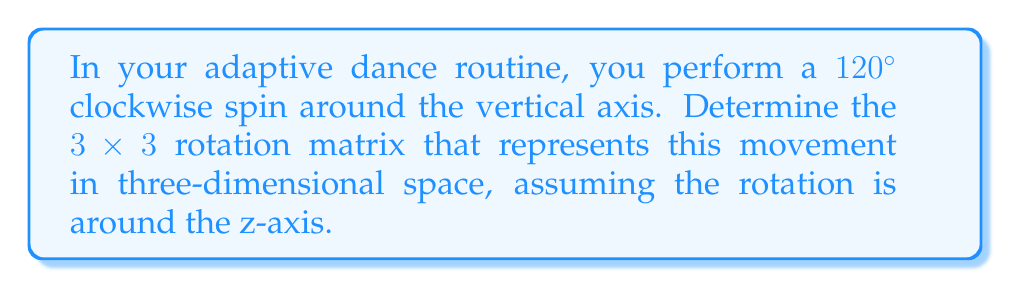Can you solve this math problem? Let's approach this step-by-step:

1) First, recall the general form of a rotation matrix around the z-axis:

   $$R_z(\theta) = \begin{bmatrix}
   \cos\theta & -\sin\theta & 0 \\
   \sin\theta & \cos\theta & 0 \\
   0 & 0 & 1
   \end{bmatrix}$$

2) In this case, we're rotating 120° clockwise. In mathematics, we typically consider counterclockwise rotations as positive. So, we need to use -120° or $-\frac{2\pi}{3}$ radians.

3) Let's calculate the sine and cosine of $-\frac{2\pi}{3}$:

   $\cos(-\frac{2\pi}{3}) = -\frac{1}{2}$
   $\sin(-\frac{2\pi}{3}) = -\frac{\sqrt{3}}{2}$

4) Now, let's substitute these values into our rotation matrix:

   $$R_z(-\frac{2\pi}{3}) = \begin{bmatrix}
   -\frac{1}{2} & \frac{\sqrt{3}}{2} & 0 \\
   -\frac{\sqrt{3}}{2} & -\frac{1}{2} & 0 \\
   0 & 0 & 1
   \end{bmatrix}$$

This matrix represents the 120° clockwise rotation in your dance spin.
Answer: $$R_z(-\frac{2\pi}{3}) = \begin{bmatrix}
-\frac{1}{2} & \frac{\sqrt{3}}{2} & 0 \\
-\frac{\sqrt{3}}{2} & -\frac{1}{2} & 0 \\
0 & 0 & 1
\end{bmatrix}$$ 